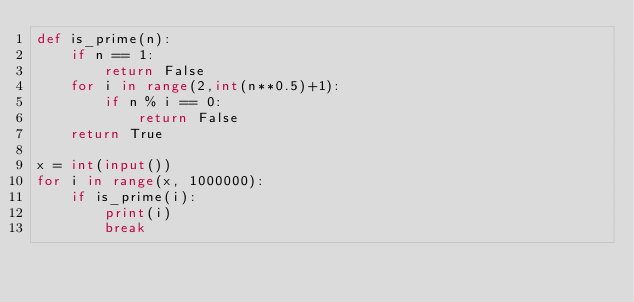Convert code to text. <code><loc_0><loc_0><loc_500><loc_500><_Python_>def is_prime(n):
    if n == 1:
        return False
    for i in range(2,int(n**0.5)+1):
        if n % i == 0:
            return False
    return True

x = int(input())
for i in range(x, 1000000):
    if is_prime(i):
        print(i)
        break</code> 